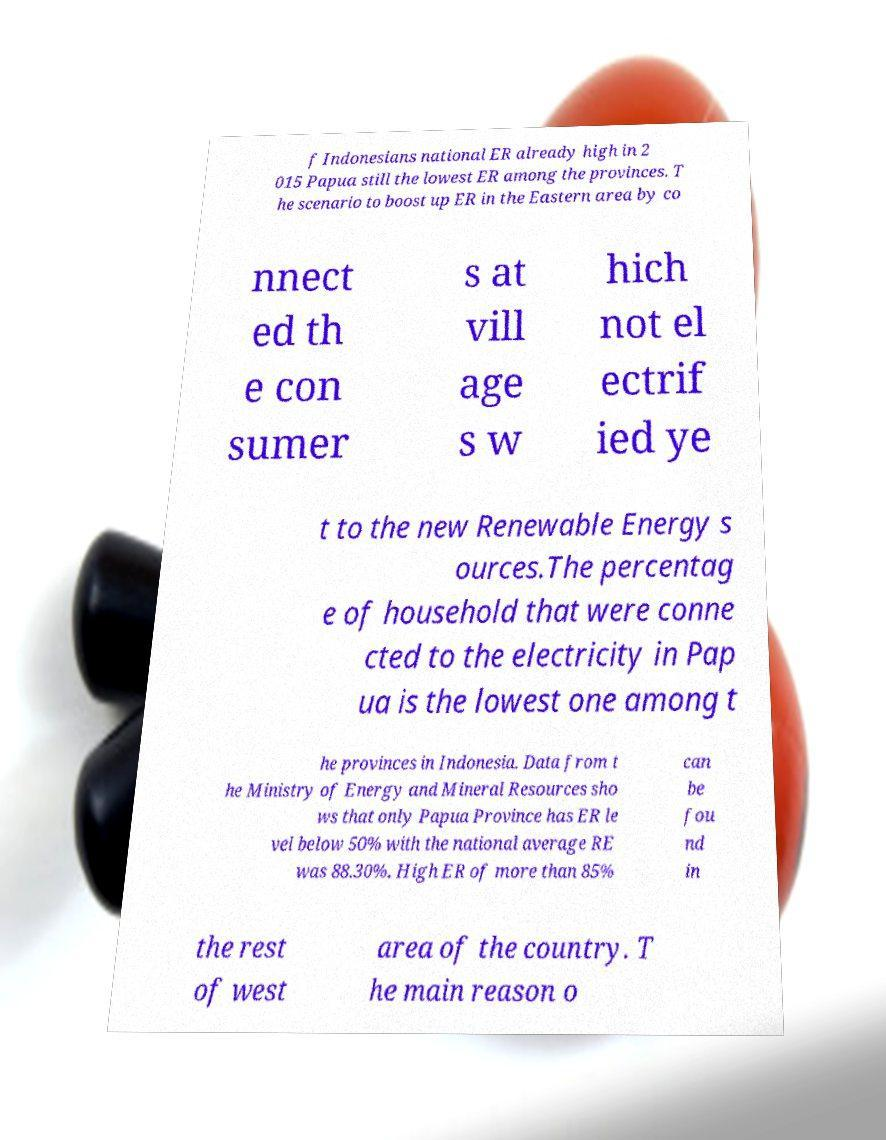Please identify and transcribe the text found in this image. f Indonesians national ER already high in 2 015 Papua still the lowest ER among the provinces. T he scenario to boost up ER in the Eastern area by co nnect ed th e con sumer s at vill age s w hich not el ectrif ied ye t to the new Renewable Energy s ources.The percentag e of household that were conne cted to the electricity in Pap ua is the lowest one among t he provinces in Indonesia. Data from t he Ministry of Energy and Mineral Resources sho ws that only Papua Province has ER le vel below 50% with the national average RE was 88.30%. High ER of more than 85% can be fou nd in the rest of west area of the country. T he main reason o 